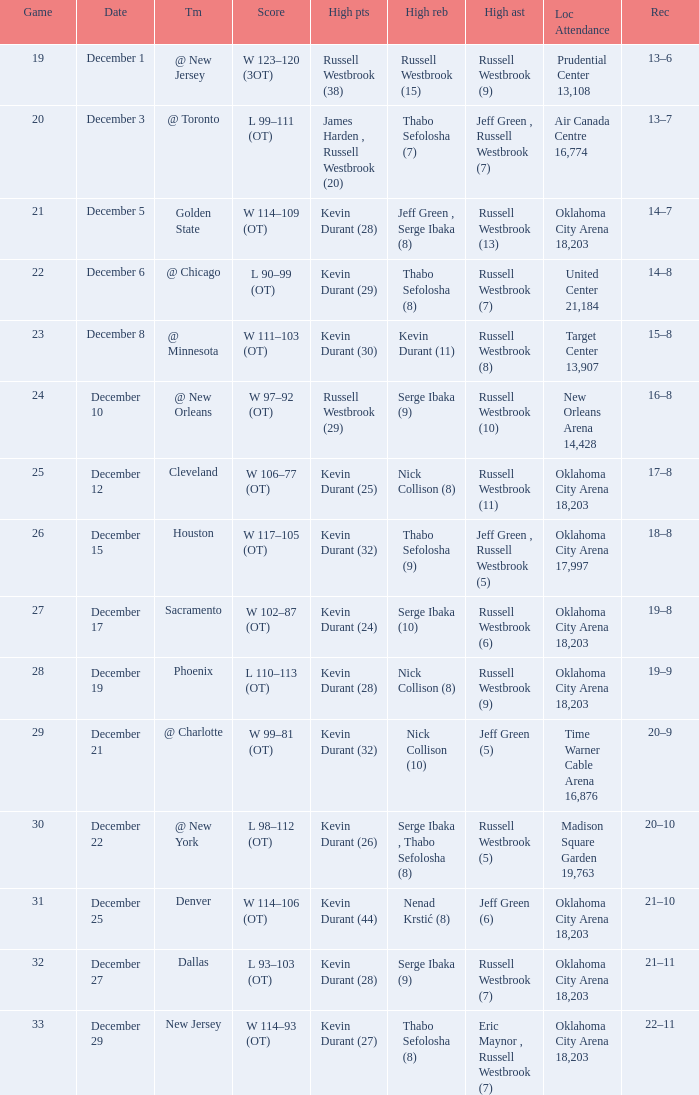What was the record on December 27? 21–11. 